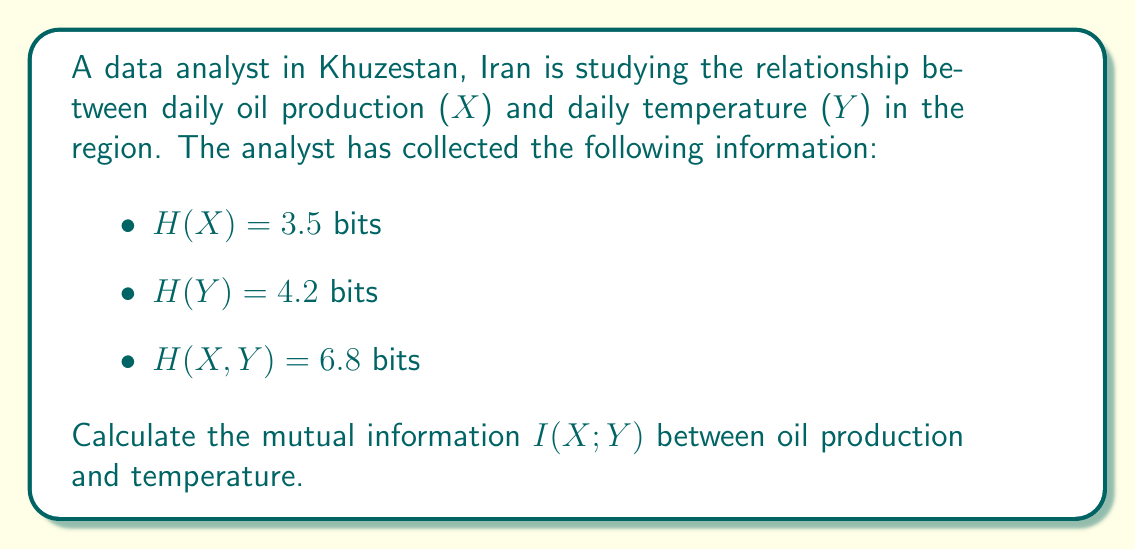Show me your answer to this math problem. To solve this problem, we need to use the relationship between entropy, joint entropy, and mutual information. The steps are as follows:

1. Recall the formula for mutual information:
   $$I(X;Y) = H(X) + H(Y) - H(X,Y)$$

   Where:
   - $I(X;Y)$ is the mutual information between X and Y
   - $H(X)$ is the entropy of X
   - $H(Y)$ is the entropy of Y
   - $H(X,Y)$ is the joint entropy of X and Y

2. We are given:
   - $H(X) = 3.5$ bits
   - $H(Y) = 4.2$ bits
   - $H(X,Y) = 6.8$ bits

3. Substitute these values into the formula:
   $$I(X;Y) = 3.5 + 4.2 - 6.8$$

4. Perform the calculation:
   $$I(X;Y) = 7.7 - 6.8 = 0.9$$

Therefore, the mutual information between daily oil production and daily temperature is 0.9 bits.
Answer: $I(X;Y) = 0.9$ bits 